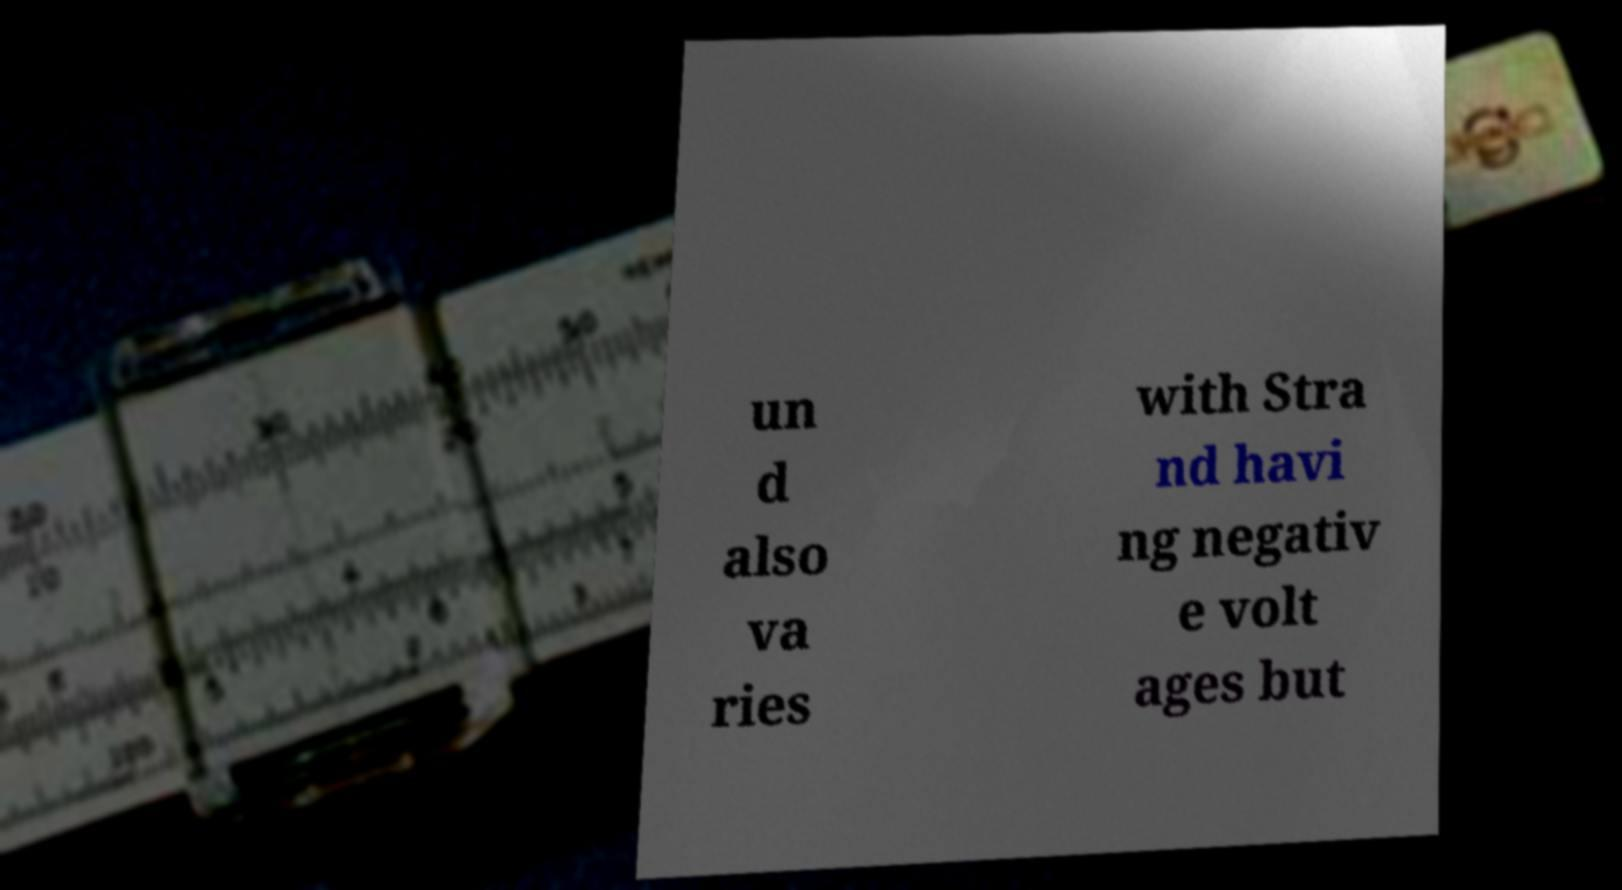I need the written content from this picture converted into text. Can you do that? un d also va ries with Stra nd havi ng negativ e volt ages but 